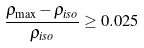<formula> <loc_0><loc_0><loc_500><loc_500>\frac { \rho _ { \max } - \rho _ { i s o } } { \rho _ { i s o } } \geq 0 . 0 2 5</formula> 